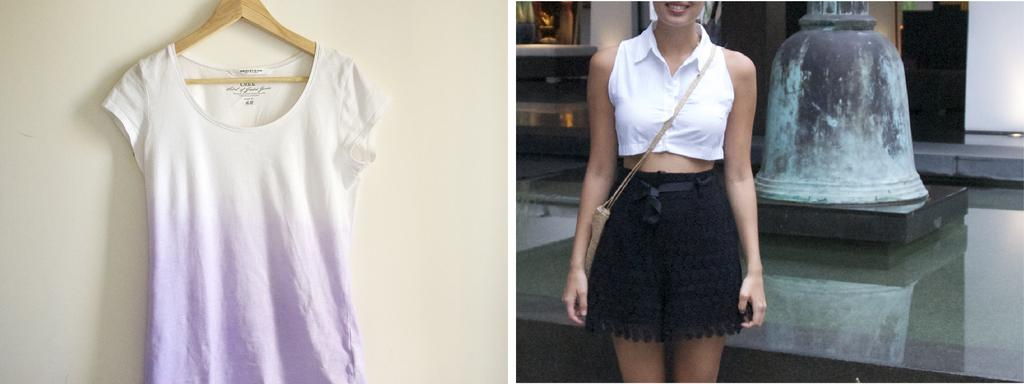What is located on the left side of the image? There is a dress on the left side of the image. What can be seen on the right side of the image? A woman is standing on the right side of the image. What color is the top that the woman is wearing? The woman is wearing a white color top. What color are the shorts that the woman is wearing? The woman is wearing black color shorts. Can you tell me how many yaks are present in the image? There are no yaks present in the image. What type of guide is assisting the woman in the image? There is no guide present in the image; it only shows a woman and a dress. 